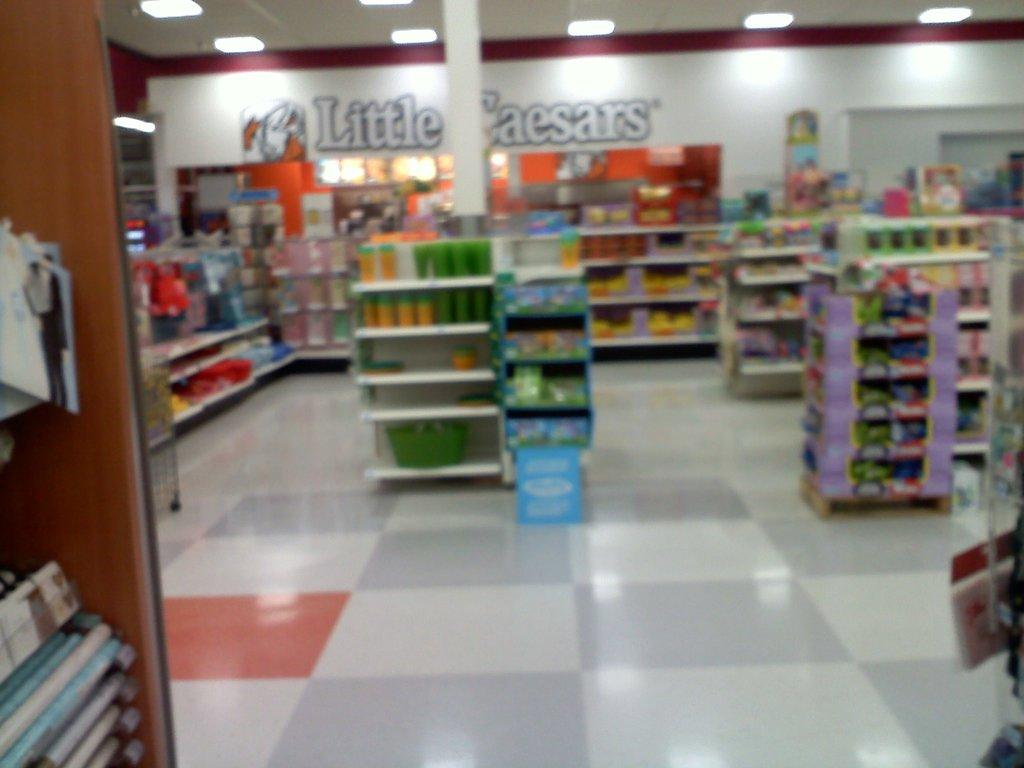<image>
Offer a succinct explanation of the picture presented. Located in this store is a Little Caesars restaurant 